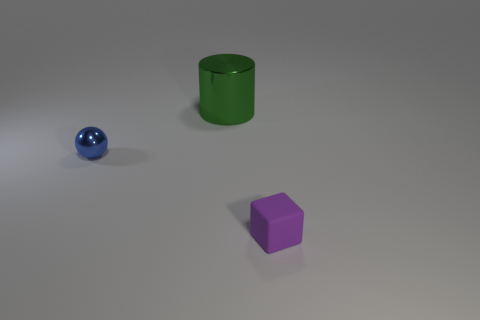Add 2 tiny purple rubber things. How many objects exist? 5 Subtract all spheres. How many objects are left? 2 Subtract all tiny green cylinders. Subtract all blue balls. How many objects are left? 2 Add 2 green things. How many green things are left? 3 Add 1 blue metallic things. How many blue metallic things exist? 2 Subtract 1 green cylinders. How many objects are left? 2 